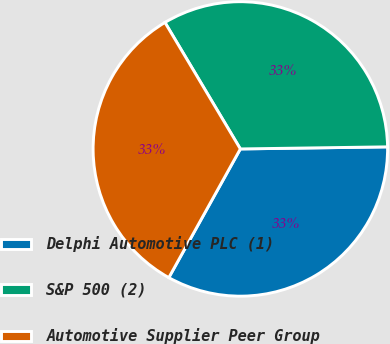<chart> <loc_0><loc_0><loc_500><loc_500><pie_chart><fcel>Delphi Automotive PLC (1)<fcel>S&P 500 (2)<fcel>Automotive Supplier Peer Group<nl><fcel>33.3%<fcel>33.33%<fcel>33.37%<nl></chart> 